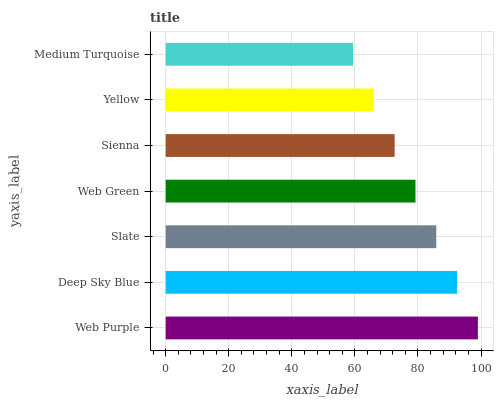Is Medium Turquoise the minimum?
Answer yes or no. Yes. Is Web Purple the maximum?
Answer yes or no. Yes. Is Deep Sky Blue the minimum?
Answer yes or no. No. Is Deep Sky Blue the maximum?
Answer yes or no. No. Is Web Purple greater than Deep Sky Blue?
Answer yes or no. Yes. Is Deep Sky Blue less than Web Purple?
Answer yes or no. Yes. Is Deep Sky Blue greater than Web Purple?
Answer yes or no. No. Is Web Purple less than Deep Sky Blue?
Answer yes or no. No. Is Web Green the high median?
Answer yes or no. Yes. Is Web Green the low median?
Answer yes or no. Yes. Is Sienna the high median?
Answer yes or no. No. Is Deep Sky Blue the low median?
Answer yes or no. No. 